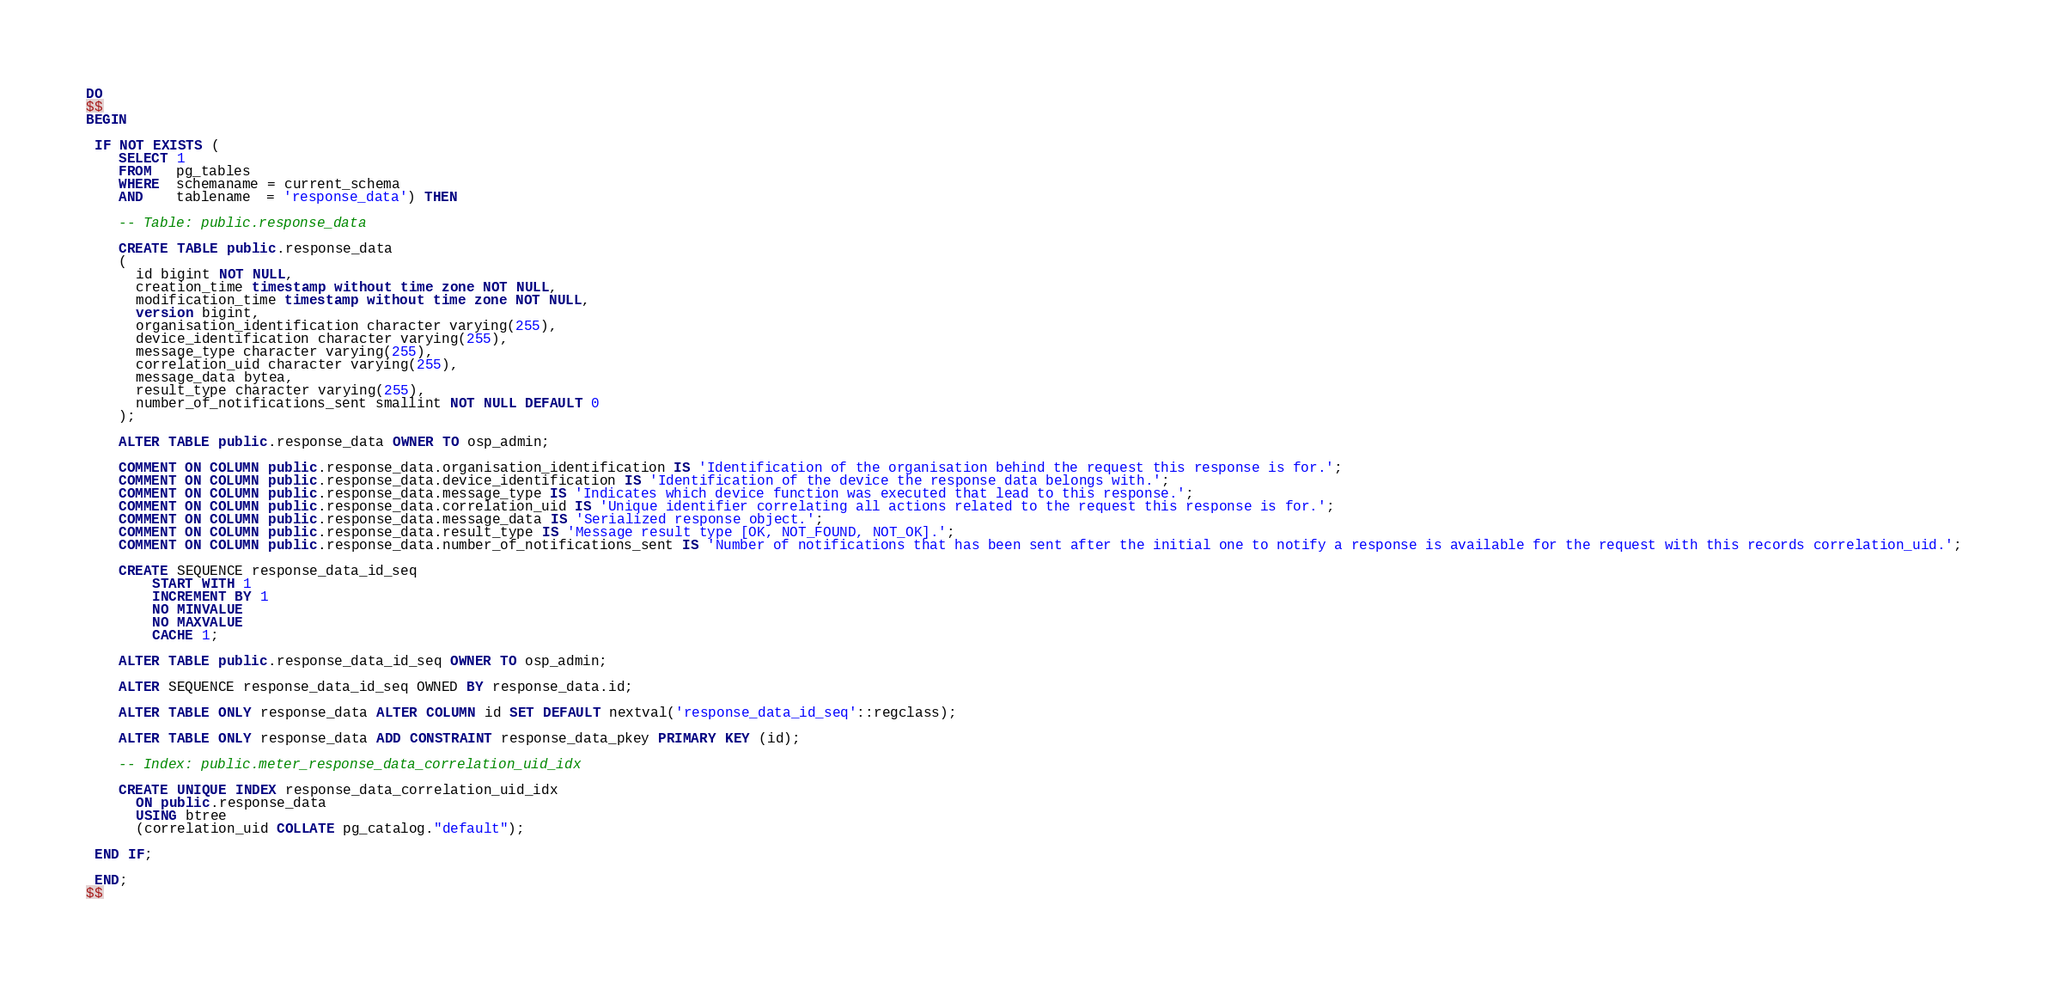<code> <loc_0><loc_0><loc_500><loc_500><_SQL_>DO
$$
BEGIN

 IF NOT EXISTS (
    SELECT 1
    FROM   pg_tables
    WHERE  schemaname = current_schema
    AND    tablename  = 'response_data') THEN

    -- Table: public.response_data

    CREATE TABLE public.response_data
    (
      id bigint NOT NULL,
      creation_time timestamp without time zone NOT NULL,
      modification_time timestamp without time zone NOT NULL,
      version bigint,
      organisation_identification character varying(255),
      device_identification character varying(255),
      message_type character varying(255),
      correlation_uid character varying(255),
      message_data bytea,
      result_type character varying(255),
      number_of_notifications_sent smallint NOT NULL DEFAULT 0
    );

    ALTER TABLE public.response_data OWNER TO osp_admin;

    COMMENT ON COLUMN public.response_data.organisation_identification IS 'Identification of the organisation behind the request this response is for.';
    COMMENT ON COLUMN public.response_data.device_identification IS 'Identification of the device the response data belongs with.';
    COMMENT ON COLUMN public.response_data.message_type IS 'Indicates which device function was executed that lead to this response.';
    COMMENT ON COLUMN public.response_data.correlation_uid IS 'Unique identifier correlating all actions related to the request this response is for.';
    COMMENT ON COLUMN public.response_data.message_data IS 'Serialized response object.';
    COMMENT ON COLUMN public.response_data.result_type IS 'Message result type [OK, NOT_FOUND, NOT_OK].';
    COMMENT ON COLUMN public.response_data.number_of_notifications_sent IS 'Number of notifications that has been sent after the initial one to notify a response is available for the request with this records correlation_uid.';

    CREATE SEQUENCE response_data_id_seq
        START WITH 1
        INCREMENT BY 1
        NO MINVALUE
        NO MAXVALUE
        CACHE 1;

    ALTER TABLE public.response_data_id_seq OWNER TO osp_admin;

    ALTER SEQUENCE response_data_id_seq OWNED BY response_data.id;

    ALTER TABLE ONLY response_data ALTER COLUMN id SET DEFAULT nextval('response_data_id_seq'::regclass);

    ALTER TABLE ONLY response_data ADD CONSTRAINT response_data_pkey PRIMARY KEY (id);

    -- Index: public.meter_response_data_correlation_uid_idx

    CREATE UNIQUE INDEX response_data_correlation_uid_idx
      ON public.response_data
      USING btree
      (correlation_uid COLLATE pg_catalog."default");

 END IF;

 END;
$$
</code> 